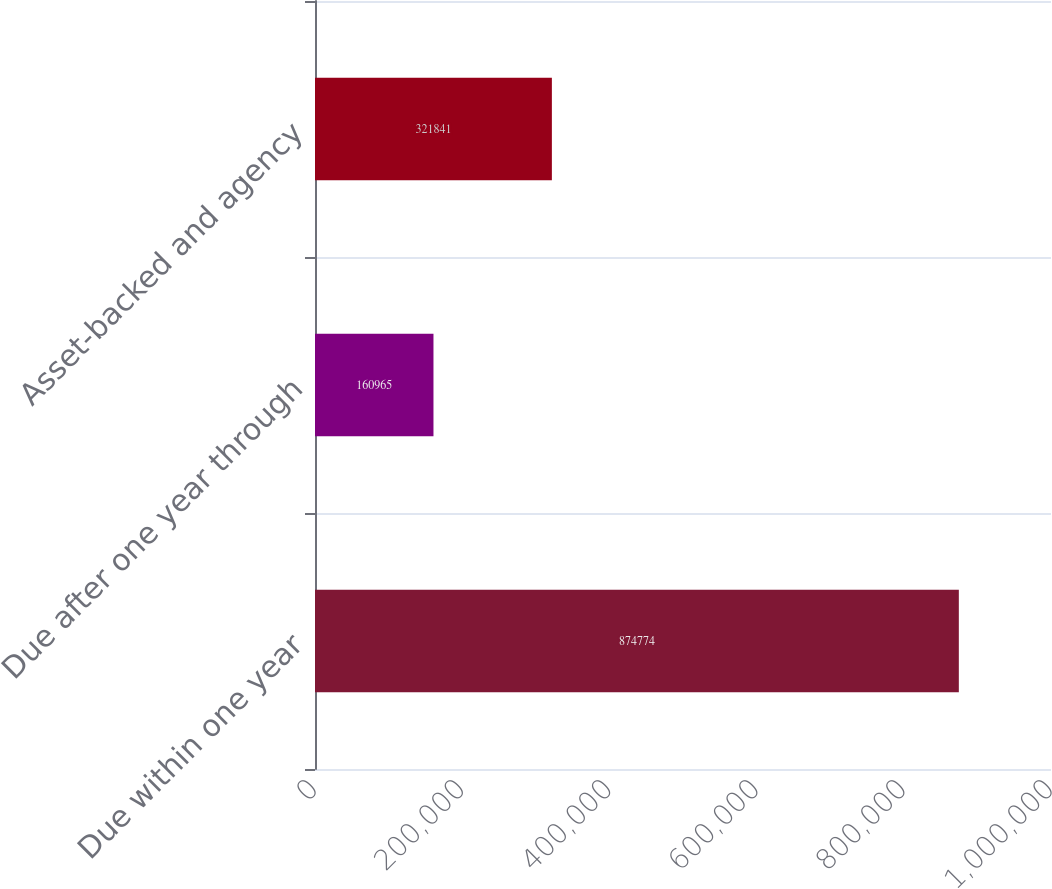Convert chart to OTSL. <chart><loc_0><loc_0><loc_500><loc_500><bar_chart><fcel>Due within one year<fcel>Due after one year through<fcel>Asset-backed and agency<nl><fcel>874774<fcel>160965<fcel>321841<nl></chart> 